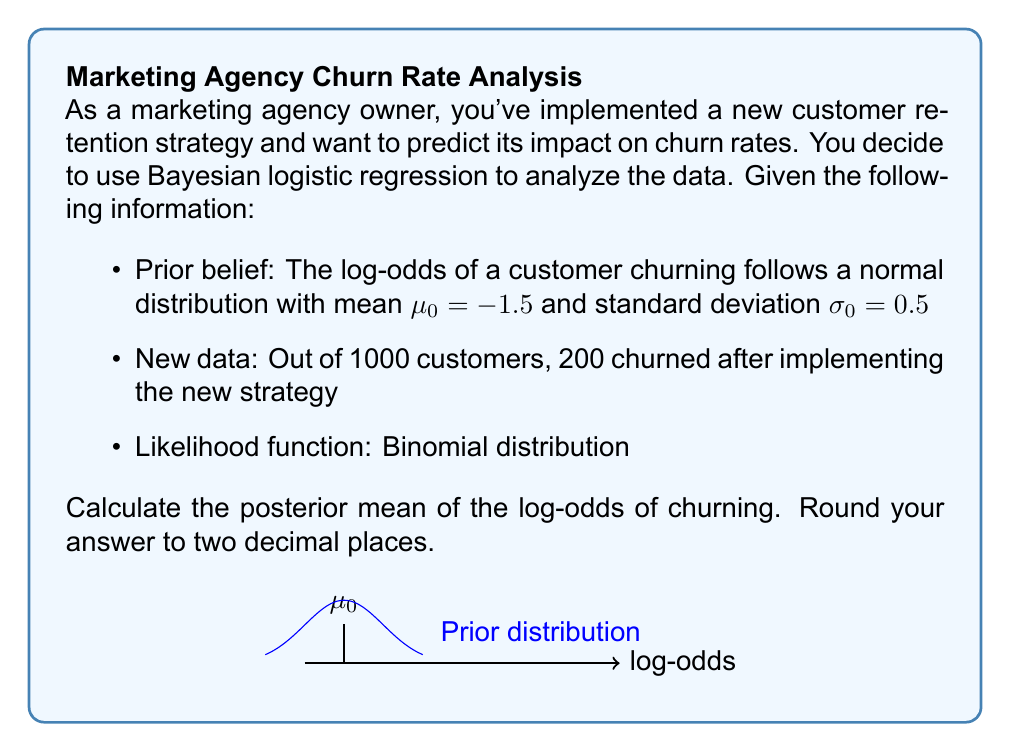Teach me how to tackle this problem. To solve this problem, we'll use Bayesian updating for logistic regression. Let's go through it step-by-step:

1) In Bayesian logistic regression, we model the log-odds of churning as:

   $$\log\left(\frac{p}{1-p}\right) = \theta$$

   where $p$ is the probability of churning and $\theta$ is our parameter of interest.

2) Our prior distribution for $\theta$ is Normal:

   $$\theta \sim N(\mu_0, \sigma_0^2) = N(-1.5, 0.5^2)$$

3) The likelihood function is Binomial:

   $$L(\theta) = \binom{n}{y} p^y (1-p)^{n-y}$$

   where $n = 1000$ (total customers) and $y = 200$ (churned customers).

4) For logistic regression, we can approximate the posterior distribution as Normal:

   $$\theta | y \sim N(\mu_n, \sigma_n^2)$$

5) The posterior mean $\mu_n$ is given by:

   $$\mu_n = \frac{\frac{\mu_0}{\sigma_0^2} + \frac{y}{n}}{\frac{1}{\sigma_0^2} + \frac{n}{4}}$$

6) Plugging in our values:

   $$\mu_n = \frac{\frac{-1.5}{0.5^2} + \frac{200}{1000}}{\frac{1}{0.5^2} + \frac{1000}{4}}$$

7) Simplifying:

   $$\mu_n = \frac{-6 + 0.2}{4 + 250} = \frac{-5.8}{254} \approx -0.02283$$

8) Rounding to two decimal places: -0.02
Answer: -0.02 